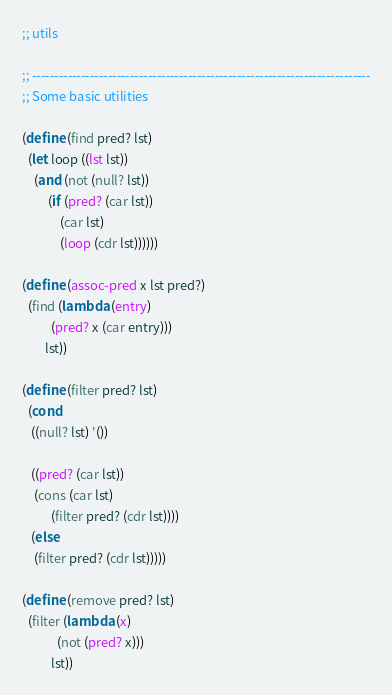Convert code to text. <code><loc_0><loc_0><loc_500><loc_500><_Scheme_>;; utils

;; ----------------------------------------------------------------------------
;; Some basic utilities

(define (find pred? lst)
  (let loop ((lst lst))
    (and (not (null? lst))
         (if (pred? (car lst))
             (car lst)
             (loop (cdr lst))))))

(define (assoc-pred x lst pred?)
  (find (lambda (entry)
          (pred? x (car entry)))
        lst))

(define (filter pred? lst)
  (cond
   ((null? lst) '())
   
   ((pred? (car lst))
    (cons (car lst)
          (filter pred? (cdr lst))))
   (else
    (filter pred? (cdr lst)))))

(define (remove pred? lst)
  (filter (lambda (x)
            (not (pred? x)))
          lst))
</code> 